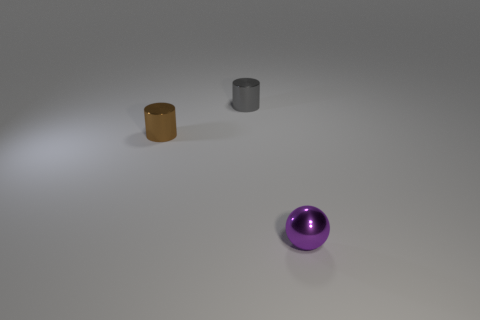Add 2 large brown metal balls. How many objects exist? 5 Subtract all spheres. How many objects are left? 2 Subtract 0 cyan blocks. How many objects are left? 3 Subtract all balls. Subtract all large green matte spheres. How many objects are left? 2 Add 1 small gray cylinders. How many small gray cylinders are left? 2 Add 2 brown metal objects. How many brown metal objects exist? 3 